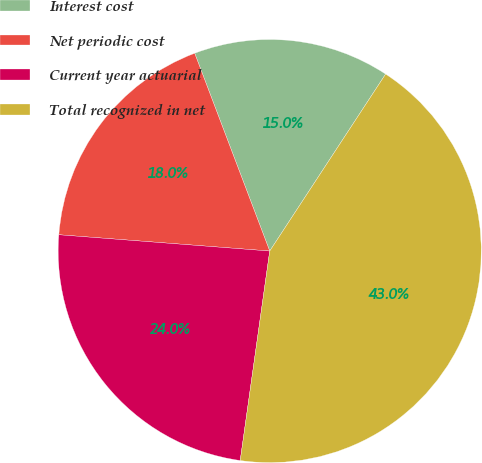<chart> <loc_0><loc_0><loc_500><loc_500><pie_chart><fcel>Interest cost<fcel>Net periodic cost<fcel>Current year actuarial<fcel>Total recognized in net<nl><fcel>15.0%<fcel>18.0%<fcel>24.0%<fcel>43.0%<nl></chart> 